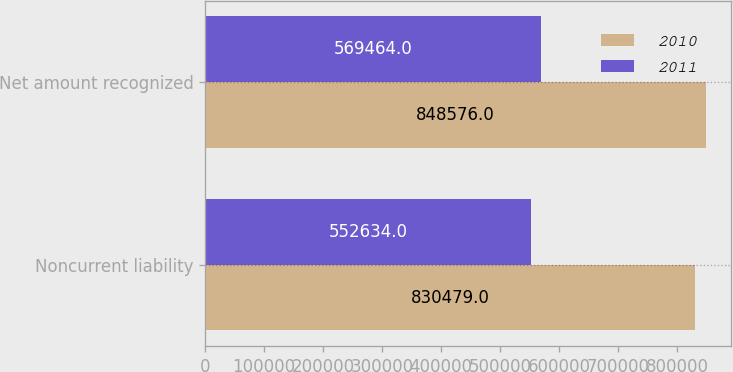Convert chart. <chart><loc_0><loc_0><loc_500><loc_500><stacked_bar_chart><ecel><fcel>Noncurrent liability<fcel>Net amount recognized<nl><fcel>2010<fcel>830479<fcel>848576<nl><fcel>2011<fcel>552634<fcel>569464<nl></chart> 